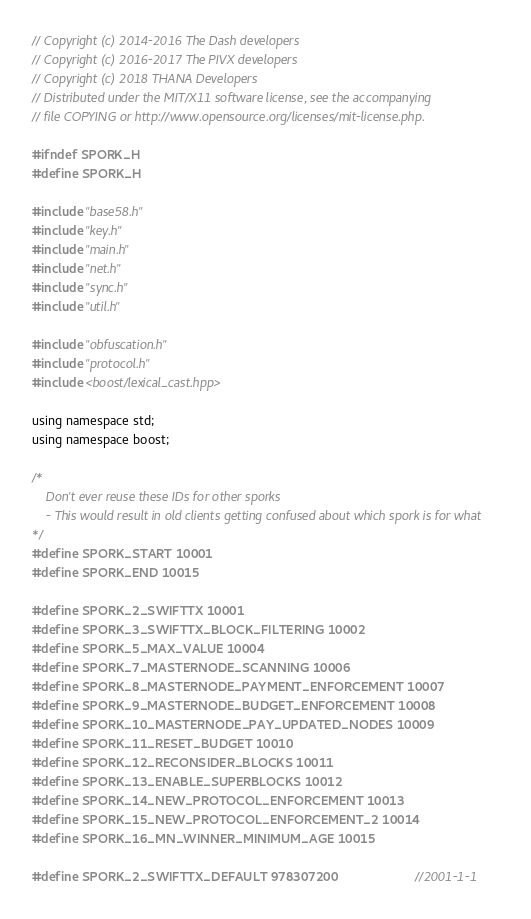Convert code to text. <code><loc_0><loc_0><loc_500><loc_500><_C_>// Copyright (c) 2014-2016 The Dash developers
// Copyright (c) 2016-2017 The PIVX developers
// Copyright (c) 2018 THANA Developers
// Distributed under the MIT/X11 software license, see the accompanying
// file COPYING or http://www.opensource.org/licenses/mit-license.php.

#ifndef SPORK_H
#define SPORK_H

#include "base58.h"
#include "key.h"
#include "main.h"
#include "net.h"
#include "sync.h"
#include "util.h"

#include "obfuscation.h"
#include "protocol.h"
#include <boost/lexical_cast.hpp>

using namespace std;
using namespace boost;

/*
    Don't ever reuse these IDs for other sporks
    - This would result in old clients getting confused about which spork is for what
*/
#define SPORK_START 10001
#define SPORK_END 10015

#define SPORK_2_SWIFTTX 10001
#define SPORK_3_SWIFTTX_BLOCK_FILTERING 10002
#define SPORK_5_MAX_VALUE 10004
#define SPORK_7_MASTERNODE_SCANNING 10006
#define SPORK_8_MASTERNODE_PAYMENT_ENFORCEMENT 10007
#define SPORK_9_MASTERNODE_BUDGET_ENFORCEMENT 10008
#define SPORK_10_MASTERNODE_PAY_UPDATED_NODES 10009
#define SPORK_11_RESET_BUDGET 10010
#define SPORK_12_RECONSIDER_BLOCKS 10011
#define SPORK_13_ENABLE_SUPERBLOCKS 10012
#define SPORK_14_NEW_PROTOCOL_ENFORCEMENT 10013
#define SPORK_15_NEW_PROTOCOL_ENFORCEMENT_2 10014
#define SPORK_16_MN_WINNER_MINIMUM_AGE 10015

#define SPORK_2_SWIFTTX_DEFAULT 978307200                         //2001-1-1</code> 